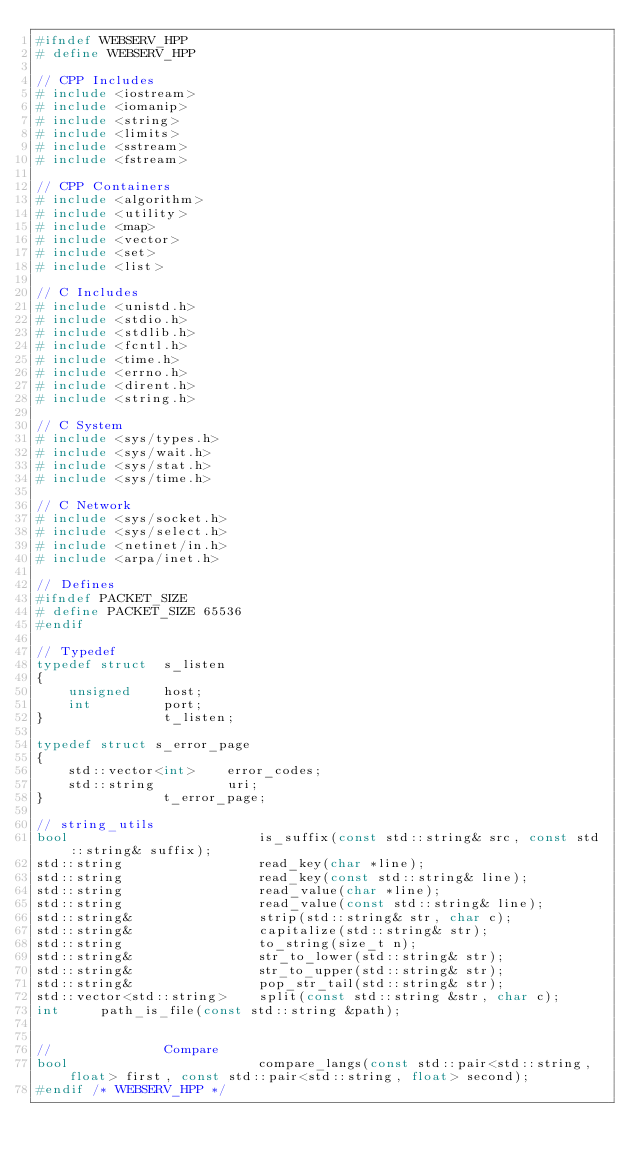<code> <loc_0><loc_0><loc_500><loc_500><_C++_>#ifndef WEBSERV_HPP
# define WEBSERV_HPP

// CPP Includes
# include <iostream>
# include <iomanip>
# include <string>
# include <limits>
# include <sstream>
# include <fstream>

// CPP Containers
# include <algorithm>
# include <utility>
# include <map>
# include <vector>
# include <set>
# include <list>

// C Includes
# include <unistd.h>
# include <stdio.h>
# include <stdlib.h>
# include <fcntl.h>
# include <time.h>
# include <errno.h>
# include <dirent.h>
# include <string.h>

// C System
# include <sys/types.h>
# include <sys/wait.h>
# include <sys/stat.h>
# include <sys/time.h>

// C Network
# include <sys/socket.h>
# include <sys/select.h>
# include <netinet/in.h>
# include <arpa/inet.h>

// Defines
#ifndef PACKET_SIZE
# define PACKET_SIZE 65536
#endif

// Typedef
typedef struct  s_listen
{
    unsigned    host;
    int         port;
}               t_listen;

typedef struct s_error_page
{
	std::vector<int>    error_codes;
	std::string         uri;
}               t_error_page;

// string_utils
bool						is_suffix(const std::string& src, const std::string& suffix);
std::string					read_key(char *line);
std::string					read_key(const std::string& line);
std::string					read_value(char *line);
std::string					read_value(const std::string& line);
std::string&				strip(std::string& str, char c);
std::string&				capitalize(std::string& str);
std::string					to_string(size_t n);
std::string&				str_to_lower(std::string& str);
std::string&				str_to_upper(std::string& str);
std::string&				pop_str_tail(std::string& str);
std::vector<std::string>	split(const std::string &str, char c);
int		path_is_file(const std::string &path);


//				Compare
bool						compare_langs(const std::pair<std::string, float> first, const std::pair<std::string, float> second);
#endif /* WEBSERV_HPP */
</code> 